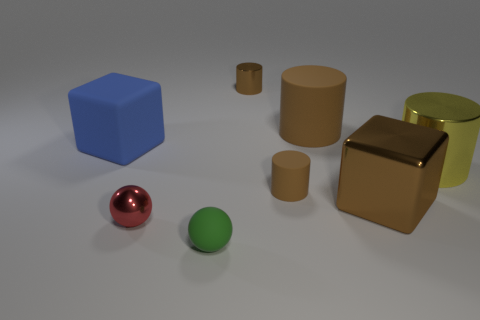There is a thing that is both behind the shiny ball and on the left side of the tiny shiny cylinder; how big is it?
Your answer should be very brief. Large. What is the shape of the blue matte thing?
Your answer should be compact. Cube. How many things are either large green objects or tiny objects that are behind the tiny matte sphere?
Make the answer very short. 3. Does the metallic cylinder on the right side of the big metallic cube have the same color as the large matte cylinder?
Ensure brevity in your answer.  No. The rubber thing that is both in front of the rubber cube and on the right side of the small rubber ball is what color?
Your response must be concise. Brown. What is the material of the large object that is to the right of the big brown metallic cube?
Your response must be concise. Metal. How big is the brown metallic cube?
Your response must be concise. Large. What number of brown things are either big cylinders or big cubes?
Offer a terse response. 2. There is a brown matte cylinder behind the large cylinder to the right of the metal block; what size is it?
Your answer should be very brief. Large. Is the color of the matte block the same as the matte cylinder that is on the right side of the small brown rubber cylinder?
Provide a succinct answer. No. 